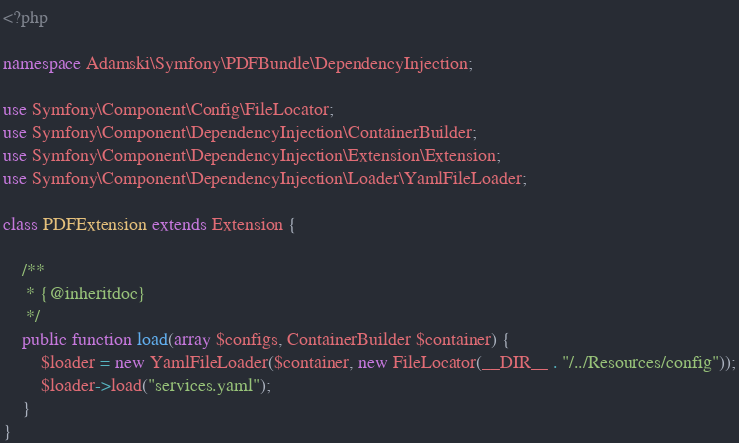Convert code to text. <code><loc_0><loc_0><loc_500><loc_500><_PHP_><?php

namespace Adamski\Symfony\PDFBundle\DependencyInjection;

use Symfony\Component\Config\FileLocator;
use Symfony\Component\DependencyInjection\ContainerBuilder;
use Symfony\Component\DependencyInjection\Extension\Extension;
use Symfony\Component\DependencyInjection\Loader\YamlFileLoader;

class PDFExtension extends Extension {

    /**
     * {@inheritdoc}
     */
    public function load(array $configs, ContainerBuilder $container) {
        $loader = new YamlFileLoader($container, new FileLocator(__DIR__ . "/../Resources/config"));
        $loader->load("services.yaml");
    }
}
</code> 